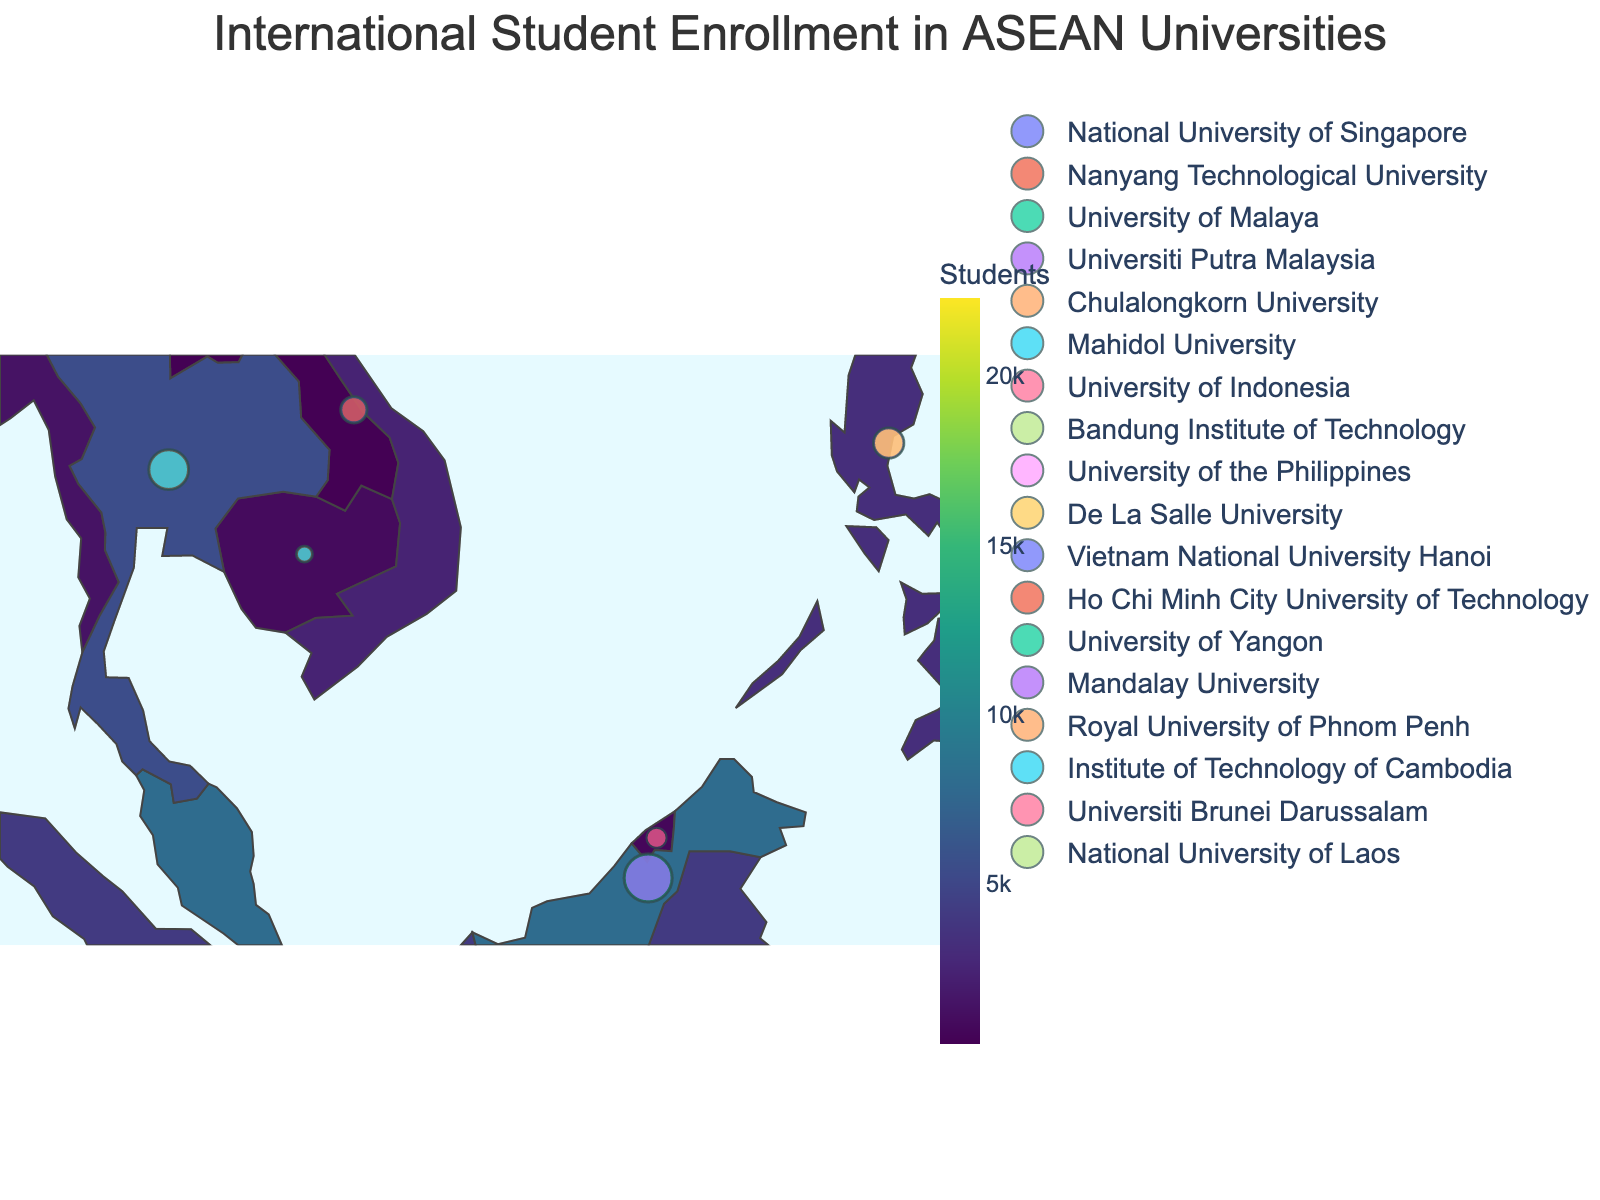How many countries in ASEAN have universities with international students represented on the map? Count the number of distinct countries labeled on the map.
Answer: 10 Which country has the highest number of international students enrolled in its universities? Identify the country with the darkest color/shade on the map, indicating the highest number of international students.
Answer: Singapore How many international students are enrolled in all Malaysian universities combined? Sum the numbers of international students for Malaysian universities: 4200 (University of Malaya) + 3800 (Universiti Putra Malaysia) = 8000.
Answer: 8000 Which university has the smallest number of international students, and in which country is it located? Look for the smallest circle on the map and check the hover information to find the university and its location.
Answer: Institute of Technology of Cambodia, Cambodia What is the difference in the number of international students between the National University of Singapore and the University of the Philippines? Subtract the number of international students at the University of the Philippines from that at the National University of Singapore: 12500 - 1700 = 10800.
Answer: 10800 How are international students in Vietnam distributed among the top universities? Look at the hover information for Vietnam's universities and note the number of international students for each: 1300 (Vietnam National University Hanoi) and 1100 (Ho Chi Minh City University of Technology).
Answer: 1300 at Vietnam National University Hanoi, 1100 at Ho Chi Minh City University of Technology Which country has the fourth highest total number of international students enrolled in its universities? 1. List the countries in descending order of the total number of international students: Singapore, Malaysia, Thailand, Indonesia.
2. Identify the fourth in the list: Indonesia.
Answer: Indonesia What is the average number of international students among universities in Myanmar? Average the numbers of international students for Myanmar universities: (800 + 600) / 2 = 700.
Answer: 700 Which countries have fewer than 1000 international students enrolled in their universities? Identify the countries with lighter colors and verify the student counts through hover information: Myanmar, Cambodia, Laos, Brunei.
Answer: Myanmar, Cambodia, Laos, Brunei What is the proportional difference in the number of international students between the National University of Laos and the National University of Singapore? Calculate the proportion:
1. Take the number of international students at each university: 12500 (National University of Singapore) and 300 (National University of Laos).
2. Find the ratio: (300 / 12500) = 0.024.
3. Convert to percentage: 0.024 × 100 = 2.4%.
Answer: 2.4% 